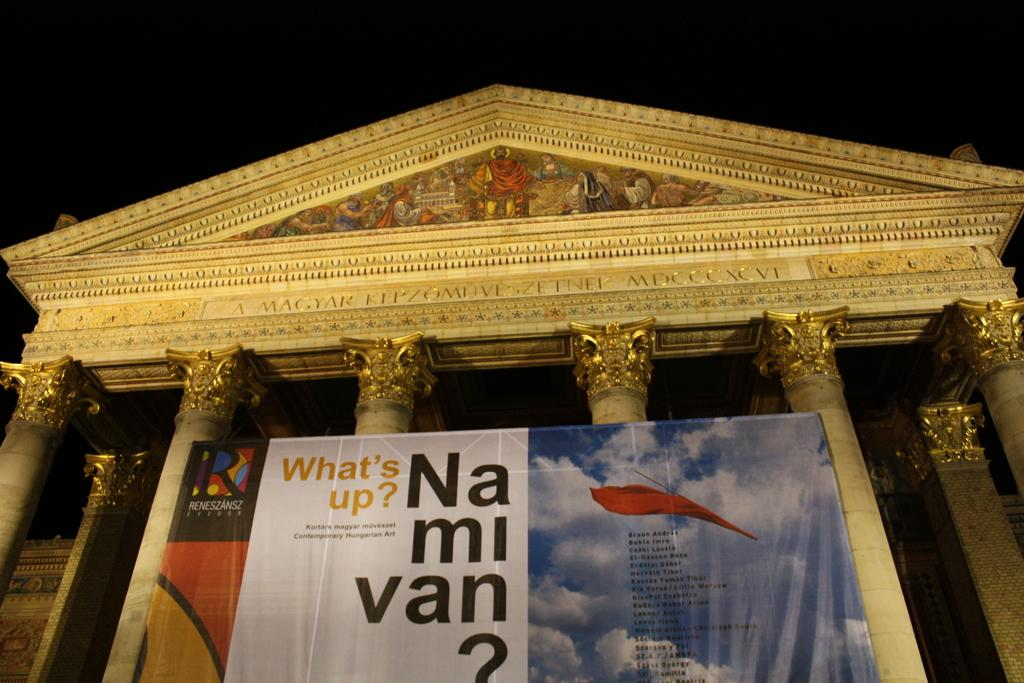What is located in the foreground of the image? There is a building, pillars, and a board with text in the foreground of the image. What specific architectural feature can be seen in the foreground? The image features pillars in the foreground. What is written or displayed on the board in the foreground? The board in the foreground has text on it. How would you describe the background of the image? The background of the image is dark. Can you tell me how many umbrellas are being held by the head in the image? There is no head or umbrella present in the image. How many dimes are scattered on the ground near the pillars in the image? There are no dimes visible on the ground in the image. 